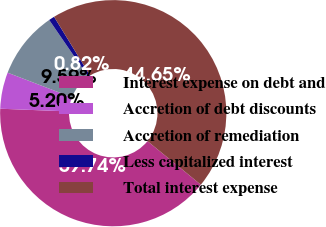Convert chart. <chart><loc_0><loc_0><loc_500><loc_500><pie_chart><fcel>Interest expense on debt and<fcel>Accretion of debt discounts<fcel>Accretion of remediation<fcel>Less capitalized interest<fcel>Total interest expense<nl><fcel>39.74%<fcel>5.2%<fcel>9.59%<fcel>0.82%<fcel>44.65%<nl></chart> 